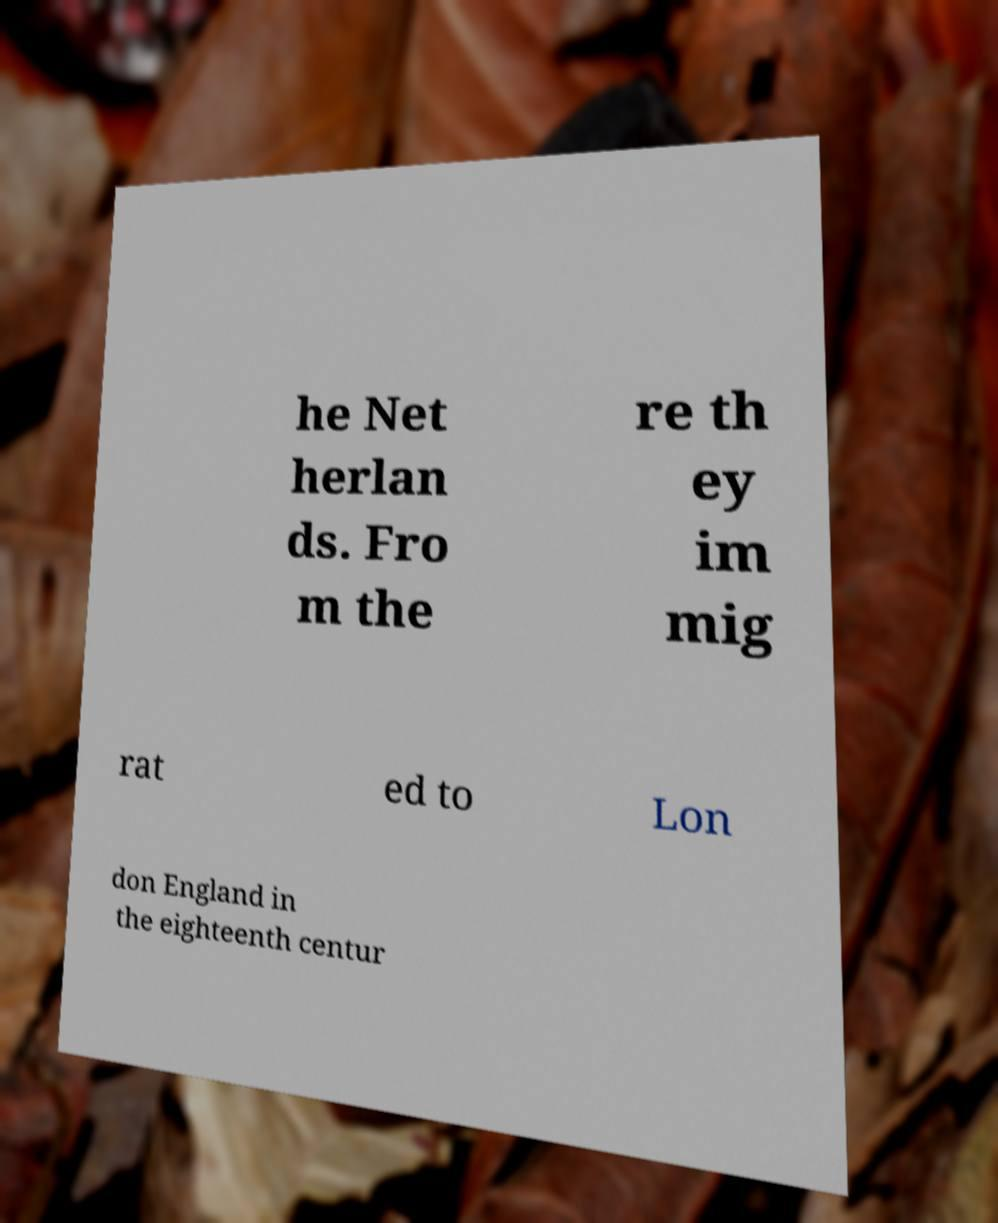Could you extract and type out the text from this image? he Net herlan ds. Fro m the re th ey im mig rat ed to Lon don England in the eighteenth centur 